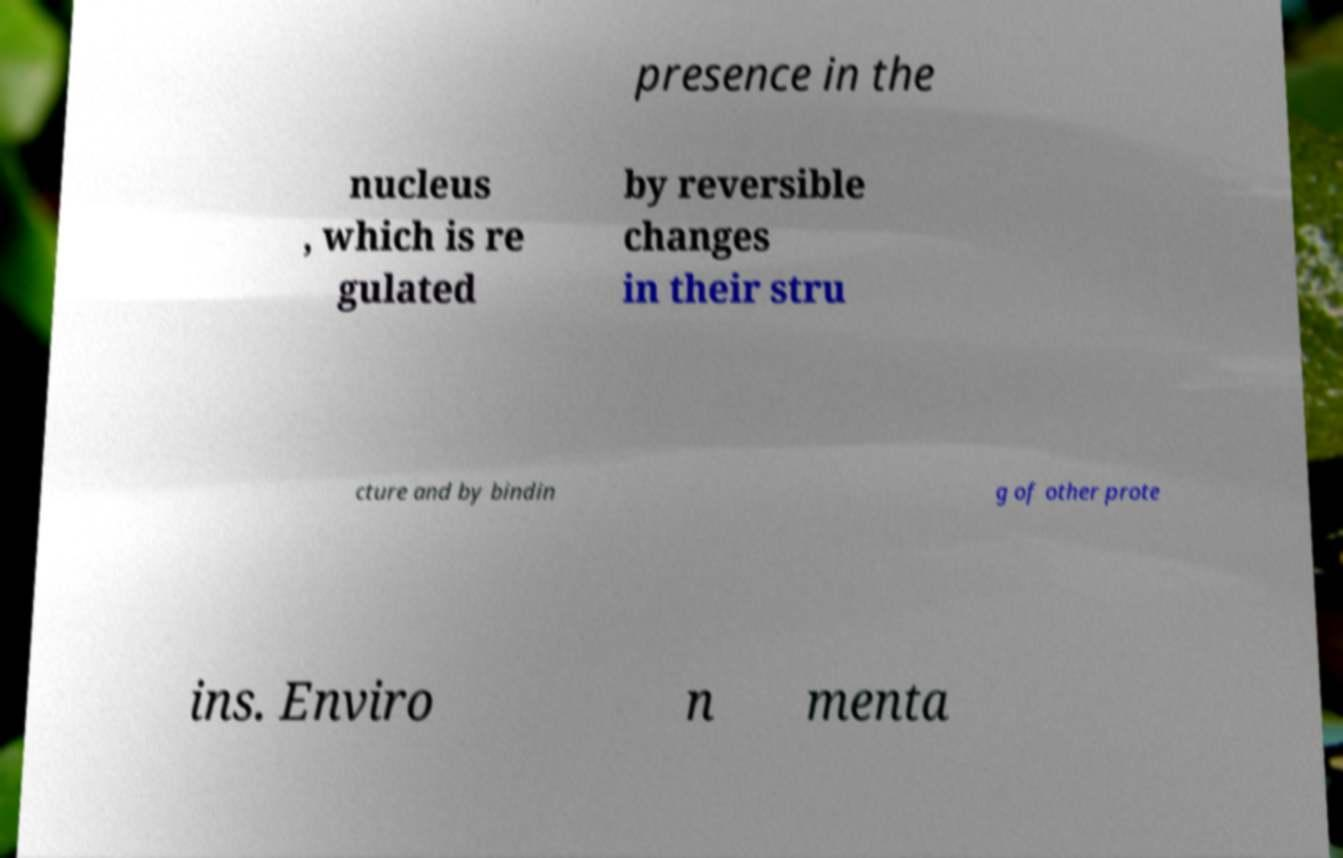Can you read and provide the text displayed in the image?This photo seems to have some interesting text. Can you extract and type it out for me? presence in the nucleus , which is re gulated by reversible changes in their stru cture and by bindin g of other prote ins. Enviro n menta 